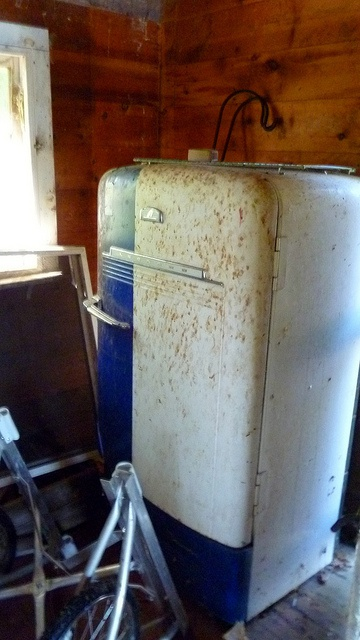Describe the objects in this image and their specific colors. I can see refrigerator in maroon, darkgray, gray, black, and lightblue tones and bicycle in maroon, black, gray, and lightblue tones in this image. 